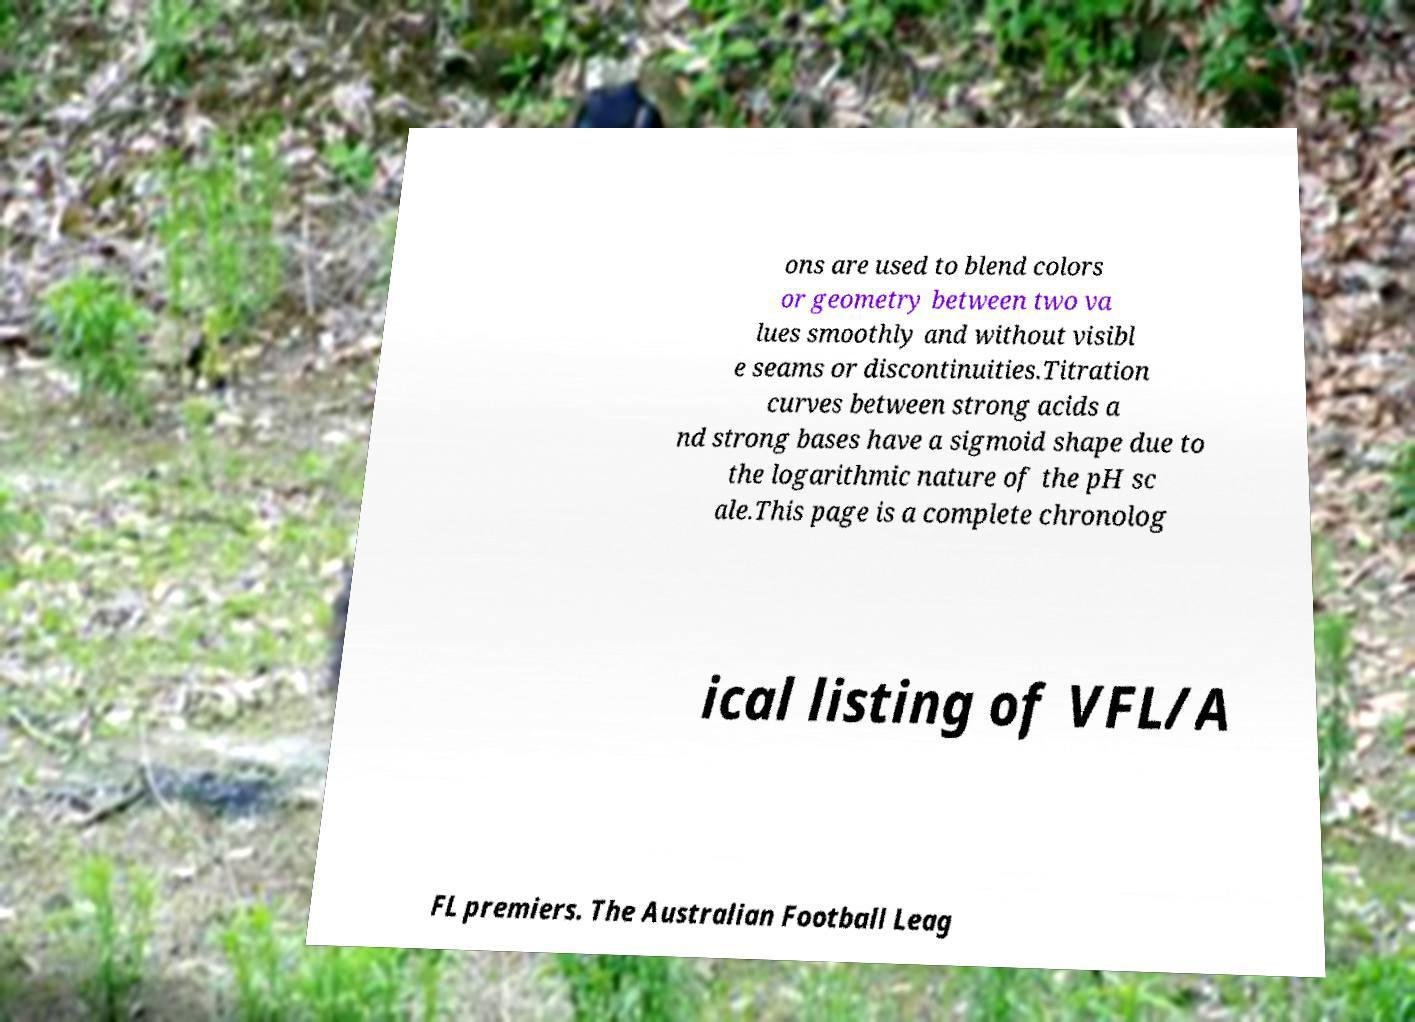Could you extract and type out the text from this image? ons are used to blend colors or geometry between two va lues smoothly and without visibl e seams or discontinuities.Titration curves between strong acids a nd strong bases have a sigmoid shape due to the logarithmic nature of the pH sc ale.This page is a complete chronolog ical listing of VFL/A FL premiers. The Australian Football Leag 